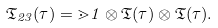Convert formula to latex. <formula><loc_0><loc_0><loc_500><loc_500>\mathfrak { T } _ { 2 3 } ( \tau ) = \mathbb { m } { 1 } \otimes \mathfrak { T } ( \tau ) \otimes \mathfrak { T } ( \tau ) .</formula> 